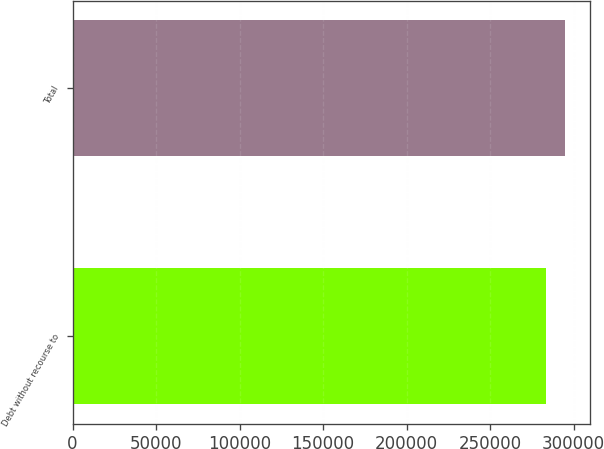Convert chart to OTSL. <chart><loc_0><loc_0><loc_500><loc_500><bar_chart><fcel>Debt without recourse to<fcel>Total<nl><fcel>283661<fcel>294918<nl></chart> 